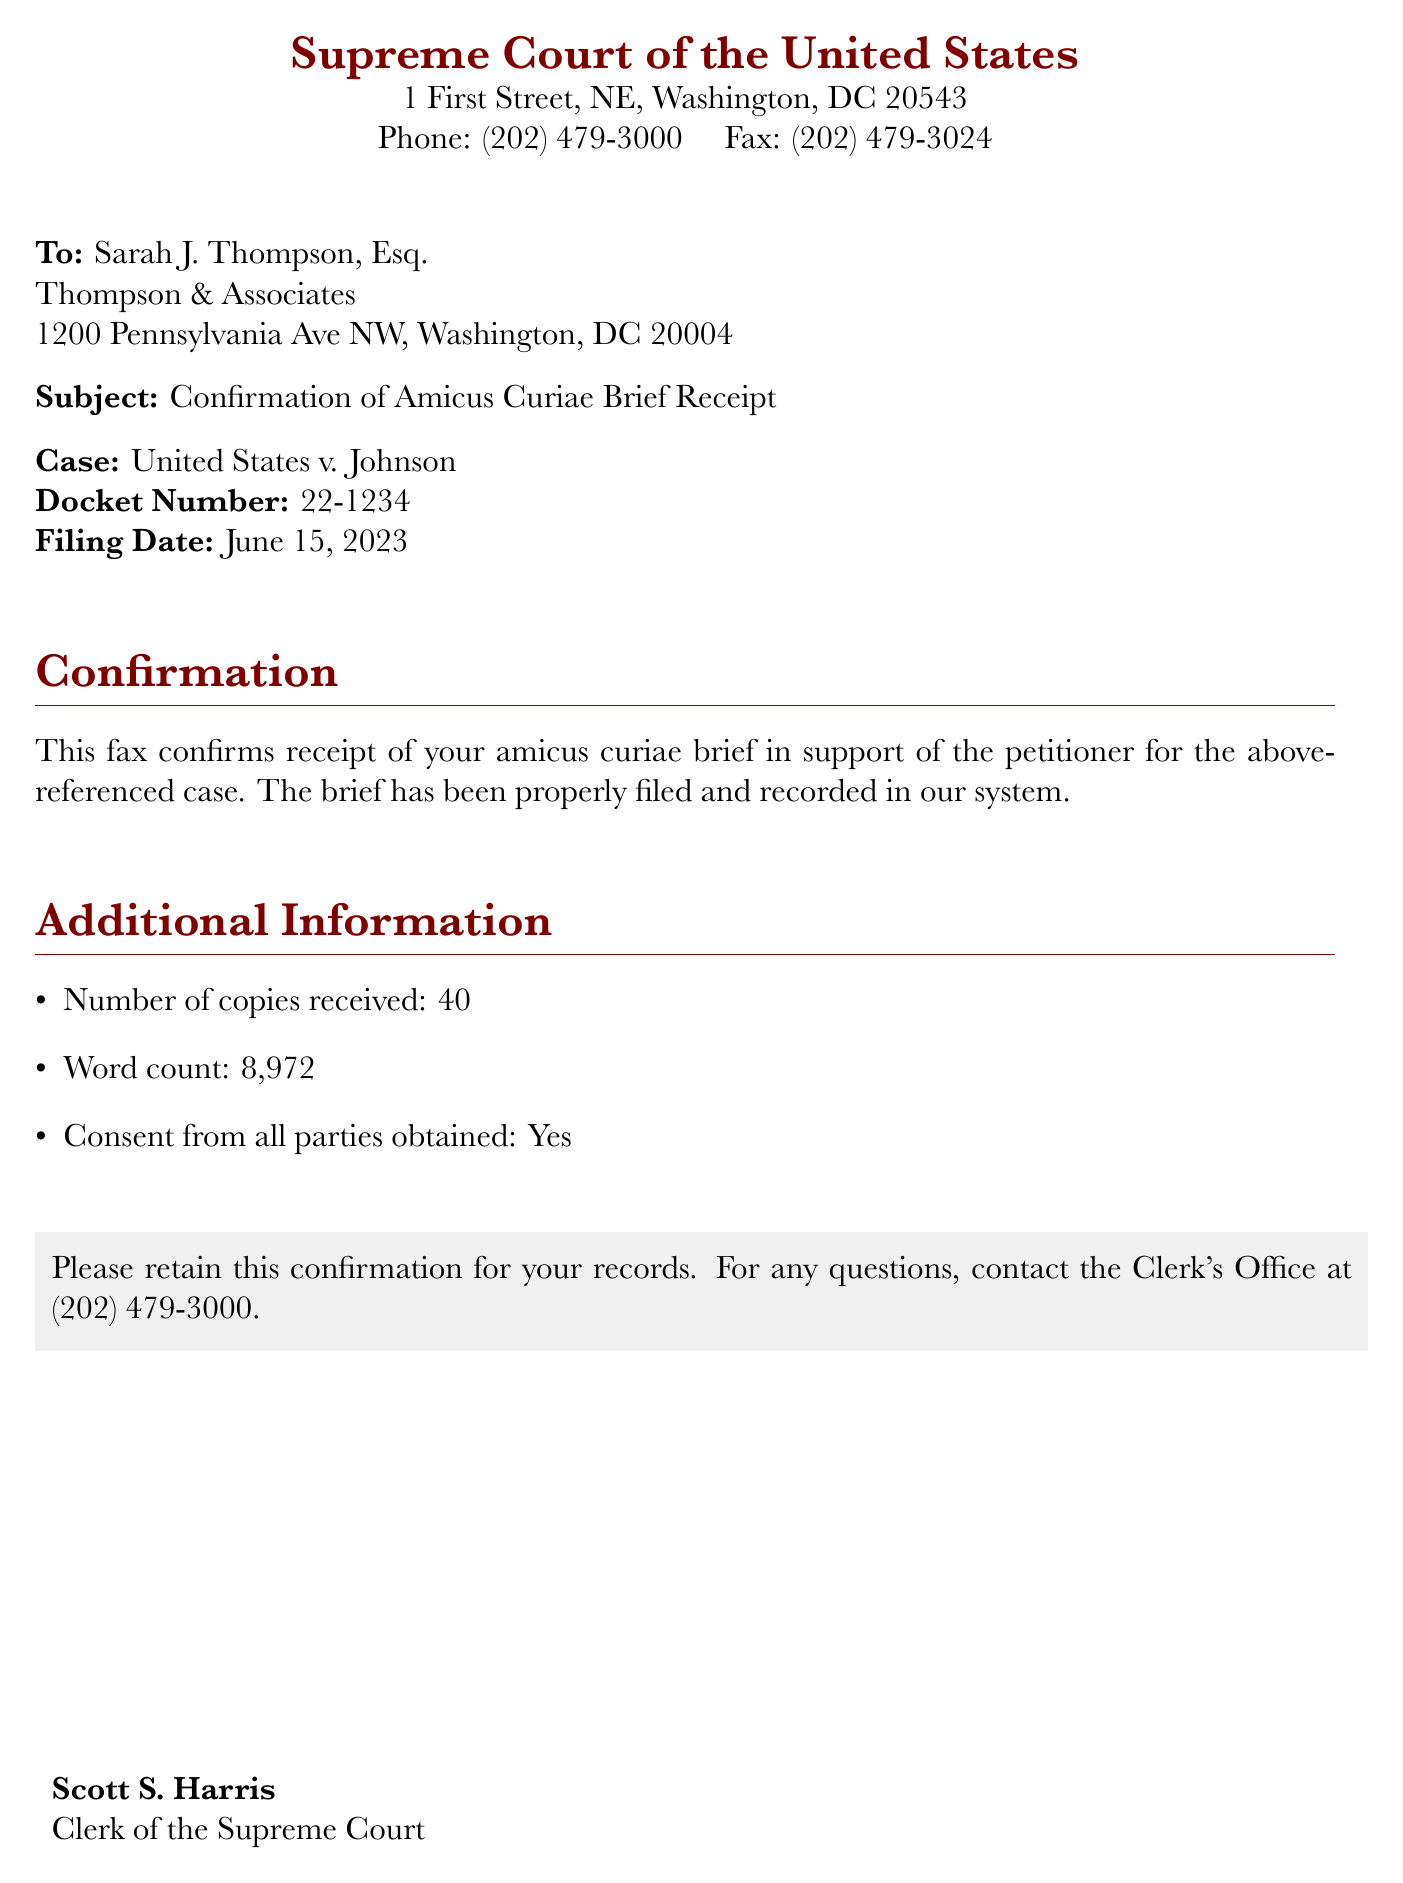What is the filing date of the brief? The filing date is explicitly stated in the document as June 15, 2023.
Answer: June 15, 2023 Who is the sender of the fax? The sender of the fax is identified at the end of the document as Scott S. Harris, Clerk of the Supreme Court.
Answer: Scott S. Harris What is the case name referenced in the fax? The case name is clearly mentioned in the subject line of the fax as United States v. Johnson.
Answer: United States v. Johnson How many copies of the brief were received? The document specifies that the number of copies received was 40.
Answer: 40 Is consent from all parties obtained? The document explicitly states that consent from all parties was obtained as "Yes."
Answer: Yes What is the docket number for the case? The docket number is provided in the fax as 22-1234.
Answer: 22-1234 What is the word count of the amicus brief? The word count is mentioned in the additional information section as 8,972.
Answer: 8,972 What should the recipient retain this confirmation for? The recipient is instructed to retain this confirmation for their records.
Answer: Records 